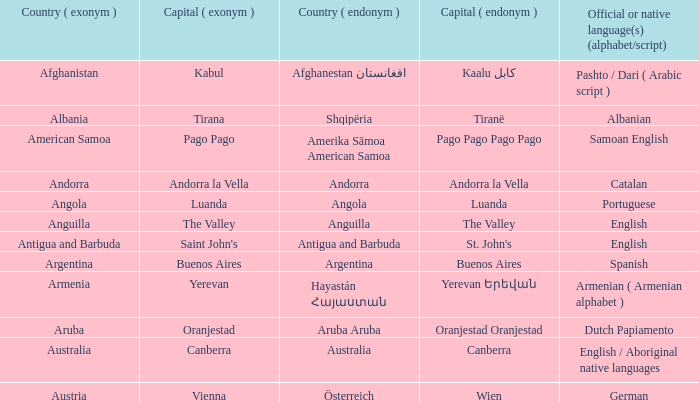What is the anglicized name assigned to the city of st. john's? Saint John's. 